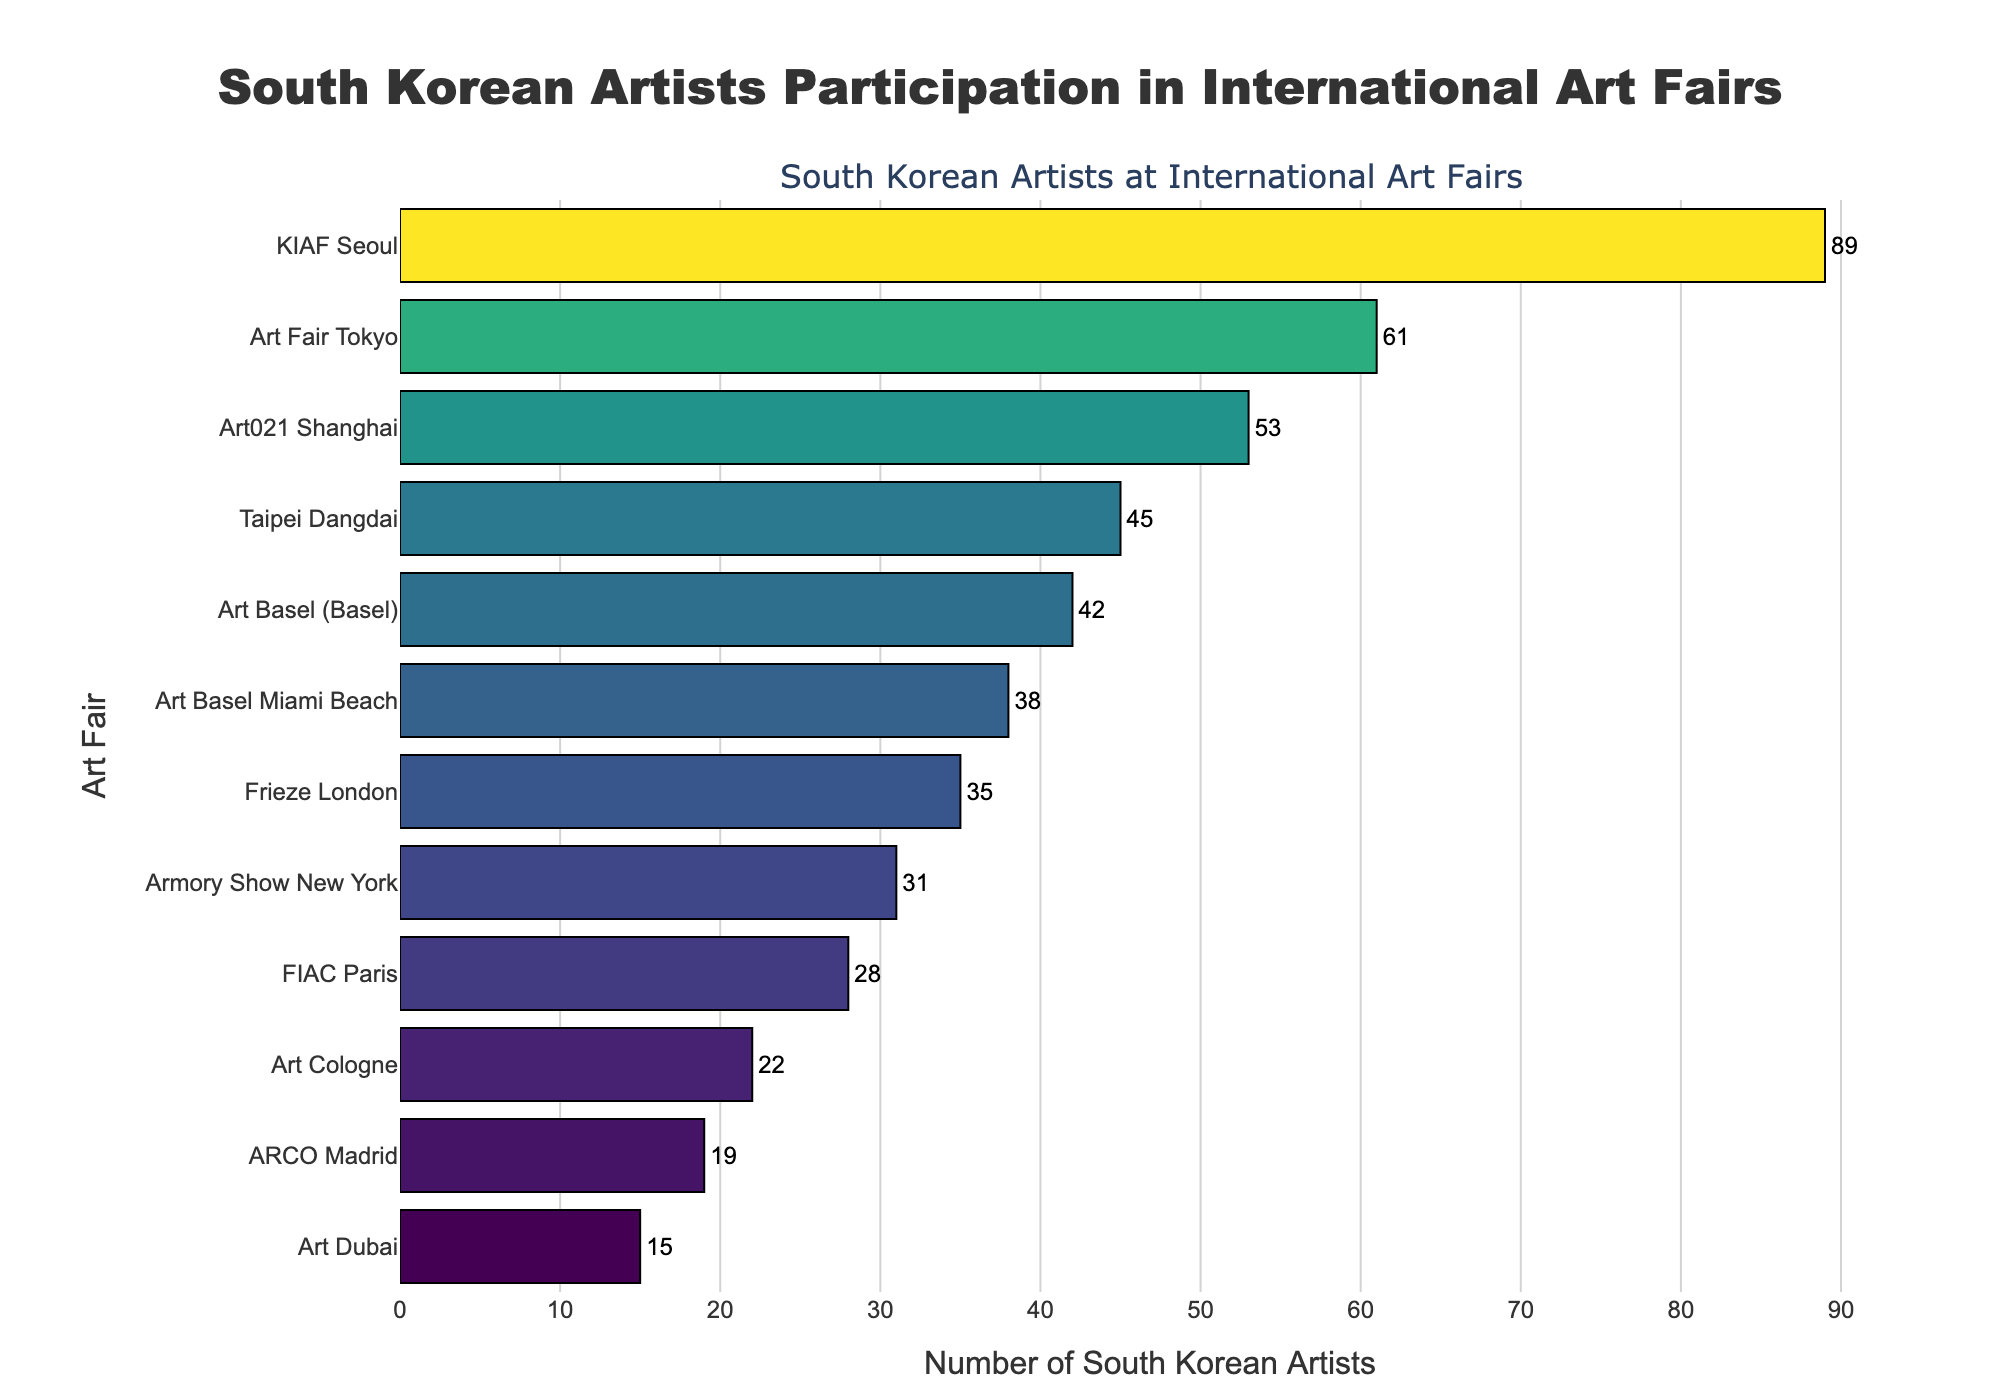Which city has the highest number of South Korean artists participating in international art fairs? The bar for KIAF Seoul is the longest, indicating that it has the highest number of artists.
Answer: Seoul Which city has the fewest South Korean artists participating in international art fairs? The bar for Art Dubai is the shortest, indicating the fewest number of artists.
Answer: Art Dubai How many more South Korean artists participated in Art Fair Tokyo compared to ARCO Madrid? Art Fair Tokyo has 61 artists while ARCO Madrid has 19. The difference is 61 - 19 = 42.
Answer: 42 What is the average number of South Korean artists participating across all art fairs? Sum all the numbers (42+35+38+28+31+22+19+15+45+53+61+89) = 478. There are 12 fairs, so the average is 478 / 12 ≈ 39.83.
Answer: 39.83 Which art fair has the most similar participation to Art Basel Miami Beach? Art Basel Miami Beach has 38 artists, and Frieze London has 35 artists, which is the closest number.
Answer: Frieze London Which cities have a number of South Korean artists participating greater than the average? The average is approximately 39.83. Cities with more than this are KIAF Seoul (89), Art Fair Tokyo (61), Art021 Shanghai (53), and Taipei Dangdai (45).
Answer: Seoul, Tokyo, Shanghai, Taipei What is the total number of South Korean artists participating in Art Basel fairs (both Basel and Miami Beach)? Art Basel (Basel) has 42 and Art Basel Miami Beach has 38. The total is 42 + 38 = 80.
Answer: 80 How does the participation in FIAC Paris compare to the Armory Show New York? FIAC Paris has 28 artists, while the Armory Show New York has 31 artists. The Armory Show has 3 more artists than FIAC Paris.
Answer: Armory Show New York has 3 more How many cities have more than 30 but less than 50 South Korean artists participating? Cities in this range are Art Basel (Basel) (42), Frieze London (35), Art Basel Miami Beach (38), and Armory Show New York (31). This makes a total of 4 cities.
Answer: 4 What is the difference in the number of South Korean artists between the city with the highest participation and the city with the lowest participation? The highest is Seoul with 89 artists, and the lowest is Art Dubai with 15 artists. The difference is 89 - 15 = 74.
Answer: 74 